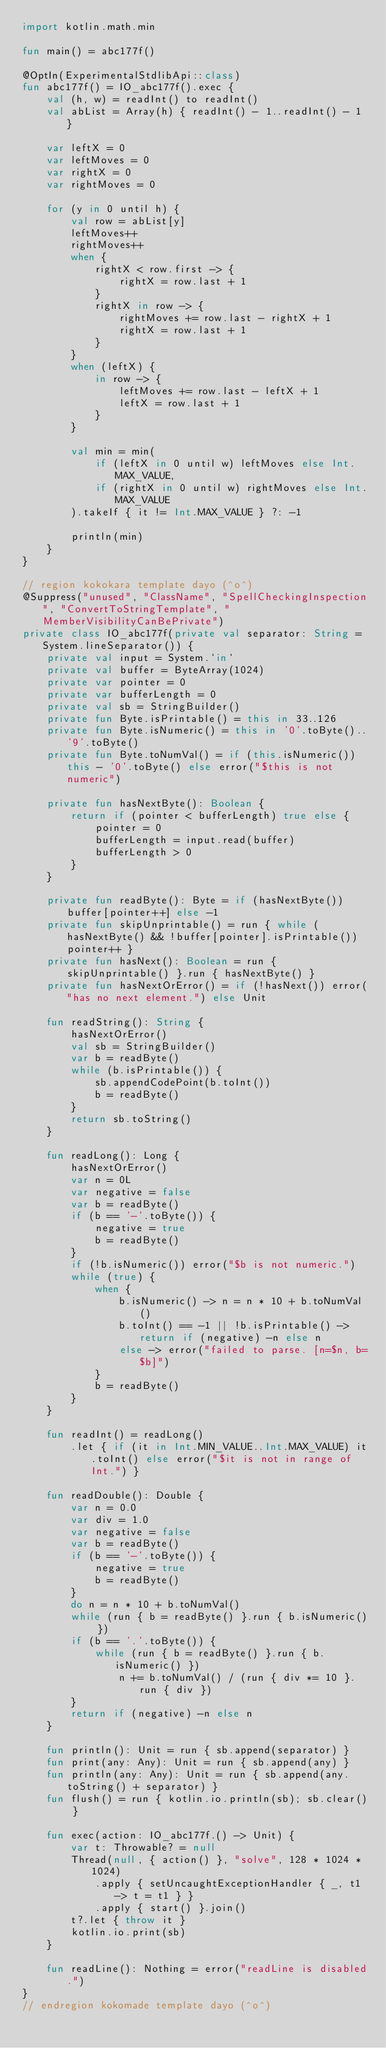<code> <loc_0><loc_0><loc_500><loc_500><_Kotlin_>import kotlin.math.min

fun main() = abc177f()

@OptIn(ExperimentalStdlibApi::class)
fun abc177f() = IO_abc177f().exec {
    val (h, w) = readInt() to readInt()
    val abList = Array(h) { readInt() - 1..readInt() - 1 }

    var leftX = 0
    var leftMoves = 0
    var rightX = 0
    var rightMoves = 0

    for (y in 0 until h) {
        val row = abList[y]
        leftMoves++
        rightMoves++
        when {
            rightX < row.first -> {
                rightX = row.last + 1
            }
            rightX in row -> {
                rightMoves += row.last - rightX + 1
                rightX = row.last + 1
            }
        }
        when (leftX) {
            in row -> {
                leftMoves += row.last - leftX + 1
                leftX = row.last + 1
            }
        }

        val min = min(
            if (leftX in 0 until w) leftMoves else Int.MAX_VALUE,
            if (rightX in 0 until w) rightMoves else Int.MAX_VALUE
        ).takeIf { it != Int.MAX_VALUE } ?: -1

        println(min)
    }
}

// region kokokara template dayo (^o^)
@Suppress("unused", "ClassName", "SpellCheckingInspection", "ConvertToStringTemplate", "MemberVisibilityCanBePrivate")
private class IO_abc177f(private val separator: String = System.lineSeparator()) {
    private val input = System.`in`
    private val buffer = ByteArray(1024)
    private var pointer = 0
    private var bufferLength = 0
    private val sb = StringBuilder()
    private fun Byte.isPrintable() = this in 33..126
    private fun Byte.isNumeric() = this in '0'.toByte()..'9'.toByte()
    private fun Byte.toNumVal() = if (this.isNumeric()) this - '0'.toByte() else error("$this is not numeric")

    private fun hasNextByte(): Boolean {
        return if (pointer < bufferLength) true else {
            pointer = 0
            bufferLength = input.read(buffer)
            bufferLength > 0
        }
    }

    private fun readByte(): Byte = if (hasNextByte()) buffer[pointer++] else -1
    private fun skipUnprintable() = run { while (hasNextByte() && !buffer[pointer].isPrintable()) pointer++ }
    private fun hasNext(): Boolean = run { skipUnprintable() }.run { hasNextByte() }
    private fun hasNextOrError() = if (!hasNext()) error("has no next element.") else Unit

    fun readString(): String {
        hasNextOrError()
        val sb = StringBuilder()
        var b = readByte()
        while (b.isPrintable()) {
            sb.appendCodePoint(b.toInt())
            b = readByte()
        }
        return sb.toString()
    }

    fun readLong(): Long {
        hasNextOrError()
        var n = 0L
        var negative = false
        var b = readByte()
        if (b == '-'.toByte()) {
            negative = true
            b = readByte()
        }
        if (!b.isNumeric()) error("$b is not numeric.")
        while (true) {
            when {
                b.isNumeric() -> n = n * 10 + b.toNumVal()
                b.toInt() == -1 || !b.isPrintable() -> return if (negative) -n else n
                else -> error("failed to parse. [n=$n, b=$b]")
            }
            b = readByte()
        }
    }

    fun readInt() = readLong()
        .let { if (it in Int.MIN_VALUE..Int.MAX_VALUE) it.toInt() else error("$it is not in range of Int.") }

    fun readDouble(): Double {
        var n = 0.0
        var div = 1.0
        var negative = false
        var b = readByte()
        if (b == '-'.toByte()) {
            negative = true
            b = readByte()
        }
        do n = n * 10 + b.toNumVal()
        while (run { b = readByte() }.run { b.isNumeric() })
        if (b == '.'.toByte()) {
            while (run { b = readByte() }.run { b.isNumeric() })
                n += b.toNumVal() / (run { div *= 10 }.run { div })
        }
        return if (negative) -n else n
    }

    fun println(): Unit = run { sb.append(separator) }
    fun print(any: Any): Unit = run { sb.append(any) }
    fun println(any: Any): Unit = run { sb.append(any.toString() + separator) }
    fun flush() = run { kotlin.io.println(sb); sb.clear() }

    fun exec(action: IO_abc177f.() -> Unit) {
        var t: Throwable? = null
        Thread(null, { action() }, "solve", 128 * 1024 * 1024)
            .apply { setUncaughtExceptionHandler { _, t1 -> t = t1 } }
            .apply { start() }.join()
        t?.let { throw it }
        kotlin.io.print(sb)
    }

    fun readLine(): Nothing = error("readLine is disabled.")
}
// endregion kokomade template dayo (^o^)
</code> 